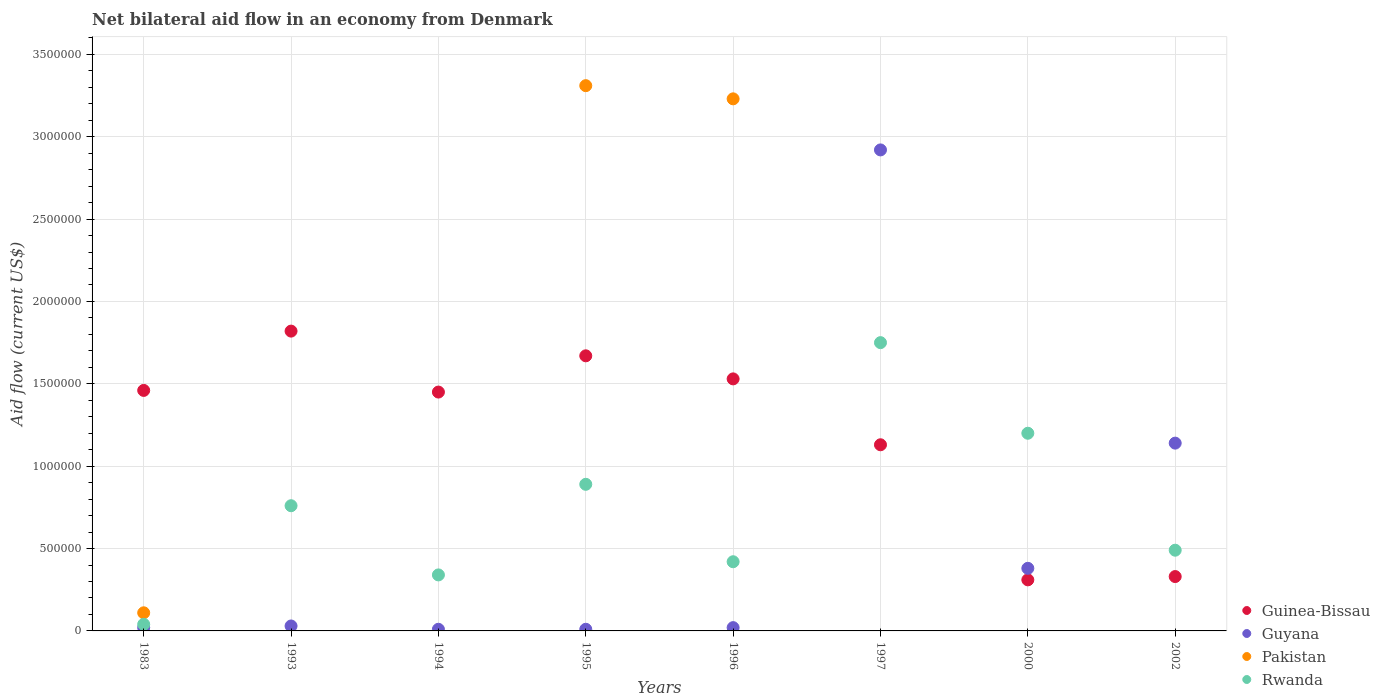How many different coloured dotlines are there?
Your answer should be very brief. 4. Across all years, what is the maximum net bilateral aid flow in Pakistan?
Ensure brevity in your answer.  3.31e+06. In which year was the net bilateral aid flow in Pakistan maximum?
Offer a very short reply. 1995. What is the total net bilateral aid flow in Guinea-Bissau in the graph?
Provide a short and direct response. 9.70e+06. What is the difference between the net bilateral aid flow in Rwanda in 1997 and the net bilateral aid flow in Pakistan in 1996?
Ensure brevity in your answer.  -1.48e+06. What is the average net bilateral aid flow in Rwanda per year?
Make the answer very short. 7.36e+05. In the year 2002, what is the difference between the net bilateral aid flow in Guyana and net bilateral aid flow in Rwanda?
Your response must be concise. 6.50e+05. In how many years, is the net bilateral aid flow in Rwanda greater than 1200000 US$?
Give a very brief answer. 1. What is the ratio of the net bilateral aid flow in Guinea-Bissau in 1996 to that in 2000?
Your response must be concise. 4.94. Is the net bilateral aid flow in Rwanda in 1983 less than that in 2002?
Give a very brief answer. Yes. What is the difference between the highest and the second highest net bilateral aid flow in Guinea-Bissau?
Offer a very short reply. 1.50e+05. What is the difference between the highest and the lowest net bilateral aid flow in Rwanda?
Your answer should be compact. 1.71e+06. Is it the case that in every year, the sum of the net bilateral aid flow in Guyana and net bilateral aid flow in Guinea-Bissau  is greater than the sum of net bilateral aid flow in Pakistan and net bilateral aid flow in Rwanda?
Offer a terse response. No. Does the net bilateral aid flow in Guinea-Bissau monotonically increase over the years?
Your answer should be very brief. No. Is the net bilateral aid flow in Pakistan strictly greater than the net bilateral aid flow in Guinea-Bissau over the years?
Keep it short and to the point. No. Is the net bilateral aid flow in Pakistan strictly less than the net bilateral aid flow in Guinea-Bissau over the years?
Make the answer very short. No. How many dotlines are there?
Offer a very short reply. 4. What is the difference between two consecutive major ticks on the Y-axis?
Keep it short and to the point. 5.00e+05. Are the values on the major ticks of Y-axis written in scientific E-notation?
Provide a short and direct response. No. Does the graph contain grids?
Provide a succinct answer. Yes. What is the title of the graph?
Your answer should be compact. Net bilateral aid flow in an economy from Denmark. Does "Belize" appear as one of the legend labels in the graph?
Ensure brevity in your answer.  No. What is the label or title of the Y-axis?
Offer a terse response. Aid flow (current US$). What is the Aid flow (current US$) of Guinea-Bissau in 1983?
Give a very brief answer. 1.46e+06. What is the Aid flow (current US$) in Guinea-Bissau in 1993?
Give a very brief answer. 1.82e+06. What is the Aid flow (current US$) in Guyana in 1993?
Provide a short and direct response. 3.00e+04. What is the Aid flow (current US$) in Rwanda in 1993?
Ensure brevity in your answer.  7.60e+05. What is the Aid flow (current US$) in Guinea-Bissau in 1994?
Offer a very short reply. 1.45e+06. What is the Aid flow (current US$) in Guyana in 1994?
Your answer should be compact. 10000. What is the Aid flow (current US$) in Rwanda in 1994?
Make the answer very short. 3.40e+05. What is the Aid flow (current US$) in Guinea-Bissau in 1995?
Ensure brevity in your answer.  1.67e+06. What is the Aid flow (current US$) in Pakistan in 1995?
Provide a short and direct response. 3.31e+06. What is the Aid flow (current US$) of Rwanda in 1995?
Make the answer very short. 8.90e+05. What is the Aid flow (current US$) of Guinea-Bissau in 1996?
Make the answer very short. 1.53e+06. What is the Aid flow (current US$) of Pakistan in 1996?
Give a very brief answer. 3.23e+06. What is the Aid flow (current US$) of Guinea-Bissau in 1997?
Ensure brevity in your answer.  1.13e+06. What is the Aid flow (current US$) in Guyana in 1997?
Ensure brevity in your answer.  2.92e+06. What is the Aid flow (current US$) of Rwanda in 1997?
Your answer should be compact. 1.75e+06. What is the Aid flow (current US$) in Pakistan in 2000?
Make the answer very short. 0. What is the Aid flow (current US$) of Rwanda in 2000?
Ensure brevity in your answer.  1.20e+06. What is the Aid flow (current US$) in Guyana in 2002?
Provide a short and direct response. 1.14e+06. Across all years, what is the maximum Aid flow (current US$) in Guinea-Bissau?
Offer a terse response. 1.82e+06. Across all years, what is the maximum Aid flow (current US$) in Guyana?
Your response must be concise. 2.92e+06. Across all years, what is the maximum Aid flow (current US$) in Pakistan?
Give a very brief answer. 3.31e+06. Across all years, what is the maximum Aid flow (current US$) of Rwanda?
Make the answer very short. 1.75e+06. Across all years, what is the minimum Aid flow (current US$) in Guinea-Bissau?
Provide a short and direct response. 3.10e+05. Across all years, what is the minimum Aid flow (current US$) in Pakistan?
Offer a terse response. 0. What is the total Aid flow (current US$) in Guinea-Bissau in the graph?
Ensure brevity in your answer.  9.70e+06. What is the total Aid flow (current US$) in Guyana in the graph?
Make the answer very short. 4.53e+06. What is the total Aid flow (current US$) of Pakistan in the graph?
Give a very brief answer. 6.65e+06. What is the total Aid flow (current US$) in Rwanda in the graph?
Your answer should be very brief. 5.89e+06. What is the difference between the Aid flow (current US$) of Guinea-Bissau in 1983 and that in 1993?
Make the answer very short. -3.60e+05. What is the difference between the Aid flow (current US$) of Guyana in 1983 and that in 1993?
Your answer should be very brief. -10000. What is the difference between the Aid flow (current US$) in Rwanda in 1983 and that in 1993?
Make the answer very short. -7.20e+05. What is the difference between the Aid flow (current US$) in Guinea-Bissau in 1983 and that in 1994?
Ensure brevity in your answer.  10000. What is the difference between the Aid flow (current US$) in Guyana in 1983 and that in 1994?
Provide a short and direct response. 10000. What is the difference between the Aid flow (current US$) of Rwanda in 1983 and that in 1994?
Provide a short and direct response. -3.00e+05. What is the difference between the Aid flow (current US$) of Guyana in 1983 and that in 1995?
Make the answer very short. 10000. What is the difference between the Aid flow (current US$) in Pakistan in 1983 and that in 1995?
Make the answer very short. -3.20e+06. What is the difference between the Aid flow (current US$) of Rwanda in 1983 and that in 1995?
Give a very brief answer. -8.50e+05. What is the difference between the Aid flow (current US$) of Guyana in 1983 and that in 1996?
Your answer should be compact. 0. What is the difference between the Aid flow (current US$) of Pakistan in 1983 and that in 1996?
Ensure brevity in your answer.  -3.12e+06. What is the difference between the Aid flow (current US$) in Rwanda in 1983 and that in 1996?
Offer a terse response. -3.80e+05. What is the difference between the Aid flow (current US$) of Guyana in 1983 and that in 1997?
Provide a succinct answer. -2.90e+06. What is the difference between the Aid flow (current US$) in Rwanda in 1983 and that in 1997?
Provide a short and direct response. -1.71e+06. What is the difference between the Aid flow (current US$) in Guinea-Bissau in 1983 and that in 2000?
Provide a short and direct response. 1.15e+06. What is the difference between the Aid flow (current US$) in Guyana in 1983 and that in 2000?
Your answer should be very brief. -3.60e+05. What is the difference between the Aid flow (current US$) of Rwanda in 1983 and that in 2000?
Keep it short and to the point. -1.16e+06. What is the difference between the Aid flow (current US$) in Guinea-Bissau in 1983 and that in 2002?
Your answer should be very brief. 1.13e+06. What is the difference between the Aid flow (current US$) in Guyana in 1983 and that in 2002?
Give a very brief answer. -1.12e+06. What is the difference between the Aid flow (current US$) in Rwanda in 1983 and that in 2002?
Offer a terse response. -4.50e+05. What is the difference between the Aid flow (current US$) in Rwanda in 1993 and that in 1994?
Offer a terse response. 4.20e+05. What is the difference between the Aid flow (current US$) of Guinea-Bissau in 1993 and that in 1995?
Offer a very short reply. 1.50e+05. What is the difference between the Aid flow (current US$) in Guyana in 1993 and that in 1995?
Keep it short and to the point. 2.00e+04. What is the difference between the Aid flow (current US$) of Guinea-Bissau in 1993 and that in 1996?
Offer a very short reply. 2.90e+05. What is the difference between the Aid flow (current US$) in Guyana in 1993 and that in 1996?
Your answer should be compact. 10000. What is the difference between the Aid flow (current US$) in Guinea-Bissau in 1993 and that in 1997?
Offer a very short reply. 6.90e+05. What is the difference between the Aid flow (current US$) in Guyana in 1993 and that in 1997?
Your answer should be very brief. -2.89e+06. What is the difference between the Aid flow (current US$) in Rwanda in 1993 and that in 1997?
Your answer should be compact. -9.90e+05. What is the difference between the Aid flow (current US$) in Guinea-Bissau in 1993 and that in 2000?
Give a very brief answer. 1.51e+06. What is the difference between the Aid flow (current US$) in Guyana in 1993 and that in 2000?
Provide a succinct answer. -3.50e+05. What is the difference between the Aid flow (current US$) of Rwanda in 1993 and that in 2000?
Your answer should be compact. -4.40e+05. What is the difference between the Aid flow (current US$) in Guinea-Bissau in 1993 and that in 2002?
Your answer should be compact. 1.49e+06. What is the difference between the Aid flow (current US$) in Guyana in 1993 and that in 2002?
Provide a short and direct response. -1.11e+06. What is the difference between the Aid flow (current US$) in Rwanda in 1993 and that in 2002?
Ensure brevity in your answer.  2.70e+05. What is the difference between the Aid flow (current US$) in Guyana in 1994 and that in 1995?
Keep it short and to the point. 0. What is the difference between the Aid flow (current US$) of Rwanda in 1994 and that in 1995?
Your answer should be very brief. -5.50e+05. What is the difference between the Aid flow (current US$) in Guinea-Bissau in 1994 and that in 1996?
Ensure brevity in your answer.  -8.00e+04. What is the difference between the Aid flow (current US$) in Rwanda in 1994 and that in 1996?
Ensure brevity in your answer.  -8.00e+04. What is the difference between the Aid flow (current US$) of Guinea-Bissau in 1994 and that in 1997?
Keep it short and to the point. 3.20e+05. What is the difference between the Aid flow (current US$) in Guyana in 1994 and that in 1997?
Give a very brief answer. -2.91e+06. What is the difference between the Aid flow (current US$) in Rwanda in 1994 and that in 1997?
Keep it short and to the point. -1.41e+06. What is the difference between the Aid flow (current US$) in Guinea-Bissau in 1994 and that in 2000?
Your response must be concise. 1.14e+06. What is the difference between the Aid flow (current US$) of Guyana in 1994 and that in 2000?
Offer a very short reply. -3.70e+05. What is the difference between the Aid flow (current US$) in Rwanda in 1994 and that in 2000?
Provide a succinct answer. -8.60e+05. What is the difference between the Aid flow (current US$) in Guinea-Bissau in 1994 and that in 2002?
Offer a terse response. 1.12e+06. What is the difference between the Aid flow (current US$) of Guyana in 1994 and that in 2002?
Give a very brief answer. -1.13e+06. What is the difference between the Aid flow (current US$) in Rwanda in 1994 and that in 2002?
Offer a terse response. -1.50e+05. What is the difference between the Aid flow (current US$) of Guinea-Bissau in 1995 and that in 1996?
Make the answer very short. 1.40e+05. What is the difference between the Aid flow (current US$) in Rwanda in 1995 and that in 1996?
Your response must be concise. 4.70e+05. What is the difference between the Aid flow (current US$) in Guinea-Bissau in 1995 and that in 1997?
Provide a succinct answer. 5.40e+05. What is the difference between the Aid flow (current US$) in Guyana in 1995 and that in 1997?
Keep it short and to the point. -2.91e+06. What is the difference between the Aid flow (current US$) of Rwanda in 1995 and that in 1997?
Make the answer very short. -8.60e+05. What is the difference between the Aid flow (current US$) in Guinea-Bissau in 1995 and that in 2000?
Your response must be concise. 1.36e+06. What is the difference between the Aid flow (current US$) of Guyana in 1995 and that in 2000?
Ensure brevity in your answer.  -3.70e+05. What is the difference between the Aid flow (current US$) in Rwanda in 1995 and that in 2000?
Your response must be concise. -3.10e+05. What is the difference between the Aid flow (current US$) in Guinea-Bissau in 1995 and that in 2002?
Your answer should be compact. 1.34e+06. What is the difference between the Aid flow (current US$) in Guyana in 1995 and that in 2002?
Offer a very short reply. -1.13e+06. What is the difference between the Aid flow (current US$) in Rwanda in 1995 and that in 2002?
Give a very brief answer. 4.00e+05. What is the difference between the Aid flow (current US$) of Guyana in 1996 and that in 1997?
Provide a succinct answer. -2.90e+06. What is the difference between the Aid flow (current US$) in Rwanda in 1996 and that in 1997?
Offer a terse response. -1.33e+06. What is the difference between the Aid flow (current US$) in Guinea-Bissau in 1996 and that in 2000?
Ensure brevity in your answer.  1.22e+06. What is the difference between the Aid flow (current US$) in Guyana in 1996 and that in 2000?
Offer a terse response. -3.60e+05. What is the difference between the Aid flow (current US$) in Rwanda in 1996 and that in 2000?
Your response must be concise. -7.80e+05. What is the difference between the Aid flow (current US$) in Guinea-Bissau in 1996 and that in 2002?
Provide a succinct answer. 1.20e+06. What is the difference between the Aid flow (current US$) in Guyana in 1996 and that in 2002?
Your response must be concise. -1.12e+06. What is the difference between the Aid flow (current US$) in Rwanda in 1996 and that in 2002?
Your answer should be very brief. -7.00e+04. What is the difference between the Aid flow (current US$) in Guinea-Bissau in 1997 and that in 2000?
Keep it short and to the point. 8.20e+05. What is the difference between the Aid flow (current US$) of Guyana in 1997 and that in 2000?
Offer a terse response. 2.54e+06. What is the difference between the Aid flow (current US$) of Rwanda in 1997 and that in 2000?
Your answer should be compact. 5.50e+05. What is the difference between the Aid flow (current US$) in Guyana in 1997 and that in 2002?
Make the answer very short. 1.78e+06. What is the difference between the Aid flow (current US$) of Rwanda in 1997 and that in 2002?
Provide a succinct answer. 1.26e+06. What is the difference between the Aid flow (current US$) of Guinea-Bissau in 2000 and that in 2002?
Provide a succinct answer. -2.00e+04. What is the difference between the Aid flow (current US$) in Guyana in 2000 and that in 2002?
Ensure brevity in your answer.  -7.60e+05. What is the difference between the Aid flow (current US$) in Rwanda in 2000 and that in 2002?
Keep it short and to the point. 7.10e+05. What is the difference between the Aid flow (current US$) of Guinea-Bissau in 1983 and the Aid flow (current US$) of Guyana in 1993?
Provide a short and direct response. 1.43e+06. What is the difference between the Aid flow (current US$) in Guinea-Bissau in 1983 and the Aid flow (current US$) in Rwanda in 1993?
Provide a short and direct response. 7.00e+05. What is the difference between the Aid flow (current US$) in Guyana in 1983 and the Aid flow (current US$) in Rwanda in 1993?
Keep it short and to the point. -7.40e+05. What is the difference between the Aid flow (current US$) in Pakistan in 1983 and the Aid flow (current US$) in Rwanda in 1993?
Provide a short and direct response. -6.50e+05. What is the difference between the Aid flow (current US$) of Guinea-Bissau in 1983 and the Aid flow (current US$) of Guyana in 1994?
Provide a short and direct response. 1.45e+06. What is the difference between the Aid flow (current US$) in Guinea-Bissau in 1983 and the Aid flow (current US$) in Rwanda in 1994?
Ensure brevity in your answer.  1.12e+06. What is the difference between the Aid flow (current US$) in Guyana in 1983 and the Aid flow (current US$) in Rwanda in 1994?
Provide a short and direct response. -3.20e+05. What is the difference between the Aid flow (current US$) of Guinea-Bissau in 1983 and the Aid flow (current US$) of Guyana in 1995?
Provide a succinct answer. 1.45e+06. What is the difference between the Aid flow (current US$) of Guinea-Bissau in 1983 and the Aid flow (current US$) of Pakistan in 1995?
Give a very brief answer. -1.85e+06. What is the difference between the Aid flow (current US$) of Guinea-Bissau in 1983 and the Aid flow (current US$) of Rwanda in 1995?
Offer a terse response. 5.70e+05. What is the difference between the Aid flow (current US$) of Guyana in 1983 and the Aid flow (current US$) of Pakistan in 1995?
Offer a very short reply. -3.29e+06. What is the difference between the Aid flow (current US$) in Guyana in 1983 and the Aid flow (current US$) in Rwanda in 1995?
Your answer should be compact. -8.70e+05. What is the difference between the Aid flow (current US$) of Pakistan in 1983 and the Aid flow (current US$) of Rwanda in 1995?
Make the answer very short. -7.80e+05. What is the difference between the Aid flow (current US$) of Guinea-Bissau in 1983 and the Aid flow (current US$) of Guyana in 1996?
Offer a very short reply. 1.44e+06. What is the difference between the Aid flow (current US$) in Guinea-Bissau in 1983 and the Aid flow (current US$) in Pakistan in 1996?
Make the answer very short. -1.77e+06. What is the difference between the Aid flow (current US$) of Guinea-Bissau in 1983 and the Aid flow (current US$) of Rwanda in 1996?
Give a very brief answer. 1.04e+06. What is the difference between the Aid flow (current US$) of Guyana in 1983 and the Aid flow (current US$) of Pakistan in 1996?
Ensure brevity in your answer.  -3.21e+06. What is the difference between the Aid flow (current US$) of Guyana in 1983 and the Aid flow (current US$) of Rwanda in 1996?
Give a very brief answer. -4.00e+05. What is the difference between the Aid flow (current US$) in Pakistan in 1983 and the Aid flow (current US$) in Rwanda in 1996?
Keep it short and to the point. -3.10e+05. What is the difference between the Aid flow (current US$) of Guinea-Bissau in 1983 and the Aid flow (current US$) of Guyana in 1997?
Ensure brevity in your answer.  -1.46e+06. What is the difference between the Aid flow (current US$) of Guyana in 1983 and the Aid flow (current US$) of Rwanda in 1997?
Offer a very short reply. -1.73e+06. What is the difference between the Aid flow (current US$) in Pakistan in 1983 and the Aid flow (current US$) in Rwanda in 1997?
Ensure brevity in your answer.  -1.64e+06. What is the difference between the Aid flow (current US$) in Guinea-Bissau in 1983 and the Aid flow (current US$) in Guyana in 2000?
Your answer should be very brief. 1.08e+06. What is the difference between the Aid flow (current US$) in Guinea-Bissau in 1983 and the Aid flow (current US$) in Rwanda in 2000?
Provide a succinct answer. 2.60e+05. What is the difference between the Aid flow (current US$) in Guyana in 1983 and the Aid flow (current US$) in Rwanda in 2000?
Provide a succinct answer. -1.18e+06. What is the difference between the Aid flow (current US$) of Pakistan in 1983 and the Aid flow (current US$) of Rwanda in 2000?
Your response must be concise. -1.09e+06. What is the difference between the Aid flow (current US$) in Guinea-Bissau in 1983 and the Aid flow (current US$) in Rwanda in 2002?
Your answer should be compact. 9.70e+05. What is the difference between the Aid flow (current US$) in Guyana in 1983 and the Aid flow (current US$) in Rwanda in 2002?
Make the answer very short. -4.70e+05. What is the difference between the Aid flow (current US$) in Pakistan in 1983 and the Aid flow (current US$) in Rwanda in 2002?
Your response must be concise. -3.80e+05. What is the difference between the Aid flow (current US$) in Guinea-Bissau in 1993 and the Aid flow (current US$) in Guyana in 1994?
Keep it short and to the point. 1.81e+06. What is the difference between the Aid flow (current US$) in Guinea-Bissau in 1993 and the Aid flow (current US$) in Rwanda in 1994?
Provide a short and direct response. 1.48e+06. What is the difference between the Aid flow (current US$) of Guyana in 1993 and the Aid flow (current US$) of Rwanda in 1994?
Provide a short and direct response. -3.10e+05. What is the difference between the Aid flow (current US$) of Guinea-Bissau in 1993 and the Aid flow (current US$) of Guyana in 1995?
Ensure brevity in your answer.  1.81e+06. What is the difference between the Aid flow (current US$) in Guinea-Bissau in 1993 and the Aid flow (current US$) in Pakistan in 1995?
Your answer should be compact. -1.49e+06. What is the difference between the Aid flow (current US$) in Guinea-Bissau in 1993 and the Aid flow (current US$) in Rwanda in 1995?
Provide a succinct answer. 9.30e+05. What is the difference between the Aid flow (current US$) of Guyana in 1993 and the Aid flow (current US$) of Pakistan in 1995?
Your answer should be very brief. -3.28e+06. What is the difference between the Aid flow (current US$) in Guyana in 1993 and the Aid flow (current US$) in Rwanda in 1995?
Provide a succinct answer. -8.60e+05. What is the difference between the Aid flow (current US$) of Guinea-Bissau in 1993 and the Aid flow (current US$) of Guyana in 1996?
Your answer should be very brief. 1.80e+06. What is the difference between the Aid flow (current US$) in Guinea-Bissau in 1993 and the Aid flow (current US$) in Pakistan in 1996?
Give a very brief answer. -1.41e+06. What is the difference between the Aid flow (current US$) in Guinea-Bissau in 1993 and the Aid flow (current US$) in Rwanda in 1996?
Offer a terse response. 1.40e+06. What is the difference between the Aid flow (current US$) of Guyana in 1993 and the Aid flow (current US$) of Pakistan in 1996?
Give a very brief answer. -3.20e+06. What is the difference between the Aid flow (current US$) of Guyana in 1993 and the Aid flow (current US$) of Rwanda in 1996?
Your answer should be very brief. -3.90e+05. What is the difference between the Aid flow (current US$) in Guinea-Bissau in 1993 and the Aid flow (current US$) in Guyana in 1997?
Offer a very short reply. -1.10e+06. What is the difference between the Aid flow (current US$) of Guyana in 1993 and the Aid flow (current US$) of Rwanda in 1997?
Your response must be concise. -1.72e+06. What is the difference between the Aid flow (current US$) in Guinea-Bissau in 1993 and the Aid flow (current US$) in Guyana in 2000?
Give a very brief answer. 1.44e+06. What is the difference between the Aid flow (current US$) of Guinea-Bissau in 1993 and the Aid flow (current US$) of Rwanda in 2000?
Your response must be concise. 6.20e+05. What is the difference between the Aid flow (current US$) of Guyana in 1993 and the Aid flow (current US$) of Rwanda in 2000?
Your answer should be very brief. -1.17e+06. What is the difference between the Aid flow (current US$) in Guinea-Bissau in 1993 and the Aid flow (current US$) in Guyana in 2002?
Make the answer very short. 6.80e+05. What is the difference between the Aid flow (current US$) of Guinea-Bissau in 1993 and the Aid flow (current US$) of Rwanda in 2002?
Keep it short and to the point. 1.33e+06. What is the difference between the Aid flow (current US$) of Guyana in 1993 and the Aid flow (current US$) of Rwanda in 2002?
Ensure brevity in your answer.  -4.60e+05. What is the difference between the Aid flow (current US$) in Guinea-Bissau in 1994 and the Aid flow (current US$) in Guyana in 1995?
Ensure brevity in your answer.  1.44e+06. What is the difference between the Aid flow (current US$) in Guinea-Bissau in 1994 and the Aid flow (current US$) in Pakistan in 1995?
Give a very brief answer. -1.86e+06. What is the difference between the Aid flow (current US$) in Guinea-Bissau in 1994 and the Aid flow (current US$) in Rwanda in 1995?
Offer a very short reply. 5.60e+05. What is the difference between the Aid flow (current US$) of Guyana in 1994 and the Aid flow (current US$) of Pakistan in 1995?
Keep it short and to the point. -3.30e+06. What is the difference between the Aid flow (current US$) in Guyana in 1994 and the Aid flow (current US$) in Rwanda in 1995?
Offer a very short reply. -8.80e+05. What is the difference between the Aid flow (current US$) of Guinea-Bissau in 1994 and the Aid flow (current US$) of Guyana in 1996?
Make the answer very short. 1.43e+06. What is the difference between the Aid flow (current US$) of Guinea-Bissau in 1994 and the Aid flow (current US$) of Pakistan in 1996?
Your response must be concise. -1.78e+06. What is the difference between the Aid flow (current US$) of Guinea-Bissau in 1994 and the Aid flow (current US$) of Rwanda in 1996?
Provide a short and direct response. 1.03e+06. What is the difference between the Aid flow (current US$) in Guyana in 1994 and the Aid flow (current US$) in Pakistan in 1996?
Your response must be concise. -3.22e+06. What is the difference between the Aid flow (current US$) of Guyana in 1994 and the Aid flow (current US$) of Rwanda in 1996?
Make the answer very short. -4.10e+05. What is the difference between the Aid flow (current US$) in Guinea-Bissau in 1994 and the Aid flow (current US$) in Guyana in 1997?
Provide a succinct answer. -1.47e+06. What is the difference between the Aid flow (current US$) in Guinea-Bissau in 1994 and the Aid flow (current US$) in Rwanda in 1997?
Offer a very short reply. -3.00e+05. What is the difference between the Aid flow (current US$) in Guyana in 1994 and the Aid flow (current US$) in Rwanda in 1997?
Your response must be concise. -1.74e+06. What is the difference between the Aid flow (current US$) of Guinea-Bissau in 1994 and the Aid flow (current US$) of Guyana in 2000?
Offer a terse response. 1.07e+06. What is the difference between the Aid flow (current US$) of Guyana in 1994 and the Aid flow (current US$) of Rwanda in 2000?
Give a very brief answer. -1.19e+06. What is the difference between the Aid flow (current US$) of Guinea-Bissau in 1994 and the Aid flow (current US$) of Rwanda in 2002?
Make the answer very short. 9.60e+05. What is the difference between the Aid flow (current US$) in Guyana in 1994 and the Aid flow (current US$) in Rwanda in 2002?
Keep it short and to the point. -4.80e+05. What is the difference between the Aid flow (current US$) of Guinea-Bissau in 1995 and the Aid flow (current US$) of Guyana in 1996?
Your answer should be very brief. 1.65e+06. What is the difference between the Aid flow (current US$) in Guinea-Bissau in 1995 and the Aid flow (current US$) in Pakistan in 1996?
Your answer should be compact. -1.56e+06. What is the difference between the Aid flow (current US$) in Guinea-Bissau in 1995 and the Aid flow (current US$) in Rwanda in 1996?
Ensure brevity in your answer.  1.25e+06. What is the difference between the Aid flow (current US$) in Guyana in 1995 and the Aid flow (current US$) in Pakistan in 1996?
Ensure brevity in your answer.  -3.22e+06. What is the difference between the Aid flow (current US$) in Guyana in 1995 and the Aid flow (current US$) in Rwanda in 1996?
Your response must be concise. -4.10e+05. What is the difference between the Aid flow (current US$) in Pakistan in 1995 and the Aid flow (current US$) in Rwanda in 1996?
Keep it short and to the point. 2.89e+06. What is the difference between the Aid flow (current US$) in Guinea-Bissau in 1995 and the Aid flow (current US$) in Guyana in 1997?
Provide a succinct answer. -1.25e+06. What is the difference between the Aid flow (current US$) of Guyana in 1995 and the Aid flow (current US$) of Rwanda in 1997?
Provide a succinct answer. -1.74e+06. What is the difference between the Aid flow (current US$) in Pakistan in 1995 and the Aid flow (current US$) in Rwanda in 1997?
Provide a succinct answer. 1.56e+06. What is the difference between the Aid flow (current US$) of Guinea-Bissau in 1995 and the Aid flow (current US$) of Guyana in 2000?
Provide a short and direct response. 1.29e+06. What is the difference between the Aid flow (current US$) in Guyana in 1995 and the Aid flow (current US$) in Rwanda in 2000?
Your answer should be very brief. -1.19e+06. What is the difference between the Aid flow (current US$) of Pakistan in 1995 and the Aid flow (current US$) of Rwanda in 2000?
Provide a short and direct response. 2.11e+06. What is the difference between the Aid flow (current US$) in Guinea-Bissau in 1995 and the Aid flow (current US$) in Guyana in 2002?
Make the answer very short. 5.30e+05. What is the difference between the Aid flow (current US$) in Guinea-Bissau in 1995 and the Aid flow (current US$) in Rwanda in 2002?
Keep it short and to the point. 1.18e+06. What is the difference between the Aid flow (current US$) of Guyana in 1995 and the Aid flow (current US$) of Rwanda in 2002?
Make the answer very short. -4.80e+05. What is the difference between the Aid flow (current US$) of Pakistan in 1995 and the Aid flow (current US$) of Rwanda in 2002?
Keep it short and to the point. 2.82e+06. What is the difference between the Aid flow (current US$) in Guinea-Bissau in 1996 and the Aid flow (current US$) in Guyana in 1997?
Keep it short and to the point. -1.39e+06. What is the difference between the Aid flow (current US$) of Guinea-Bissau in 1996 and the Aid flow (current US$) of Rwanda in 1997?
Offer a terse response. -2.20e+05. What is the difference between the Aid flow (current US$) of Guyana in 1996 and the Aid flow (current US$) of Rwanda in 1997?
Give a very brief answer. -1.73e+06. What is the difference between the Aid flow (current US$) of Pakistan in 1996 and the Aid flow (current US$) of Rwanda in 1997?
Give a very brief answer. 1.48e+06. What is the difference between the Aid flow (current US$) in Guinea-Bissau in 1996 and the Aid flow (current US$) in Guyana in 2000?
Ensure brevity in your answer.  1.15e+06. What is the difference between the Aid flow (current US$) in Guinea-Bissau in 1996 and the Aid flow (current US$) in Rwanda in 2000?
Your answer should be compact. 3.30e+05. What is the difference between the Aid flow (current US$) of Guyana in 1996 and the Aid flow (current US$) of Rwanda in 2000?
Provide a short and direct response. -1.18e+06. What is the difference between the Aid flow (current US$) of Pakistan in 1996 and the Aid flow (current US$) of Rwanda in 2000?
Make the answer very short. 2.03e+06. What is the difference between the Aid flow (current US$) in Guinea-Bissau in 1996 and the Aid flow (current US$) in Guyana in 2002?
Offer a very short reply. 3.90e+05. What is the difference between the Aid flow (current US$) of Guinea-Bissau in 1996 and the Aid flow (current US$) of Rwanda in 2002?
Offer a very short reply. 1.04e+06. What is the difference between the Aid flow (current US$) of Guyana in 1996 and the Aid flow (current US$) of Rwanda in 2002?
Your answer should be very brief. -4.70e+05. What is the difference between the Aid flow (current US$) in Pakistan in 1996 and the Aid flow (current US$) in Rwanda in 2002?
Your answer should be compact. 2.74e+06. What is the difference between the Aid flow (current US$) in Guinea-Bissau in 1997 and the Aid flow (current US$) in Guyana in 2000?
Make the answer very short. 7.50e+05. What is the difference between the Aid flow (current US$) of Guinea-Bissau in 1997 and the Aid flow (current US$) of Rwanda in 2000?
Provide a short and direct response. -7.00e+04. What is the difference between the Aid flow (current US$) in Guyana in 1997 and the Aid flow (current US$) in Rwanda in 2000?
Ensure brevity in your answer.  1.72e+06. What is the difference between the Aid flow (current US$) of Guinea-Bissau in 1997 and the Aid flow (current US$) of Guyana in 2002?
Give a very brief answer. -10000. What is the difference between the Aid flow (current US$) of Guinea-Bissau in 1997 and the Aid flow (current US$) of Rwanda in 2002?
Provide a succinct answer. 6.40e+05. What is the difference between the Aid flow (current US$) in Guyana in 1997 and the Aid flow (current US$) in Rwanda in 2002?
Provide a short and direct response. 2.43e+06. What is the difference between the Aid flow (current US$) of Guinea-Bissau in 2000 and the Aid flow (current US$) of Guyana in 2002?
Your answer should be very brief. -8.30e+05. What is the difference between the Aid flow (current US$) in Guinea-Bissau in 2000 and the Aid flow (current US$) in Rwanda in 2002?
Ensure brevity in your answer.  -1.80e+05. What is the average Aid flow (current US$) in Guinea-Bissau per year?
Your response must be concise. 1.21e+06. What is the average Aid flow (current US$) in Guyana per year?
Offer a terse response. 5.66e+05. What is the average Aid flow (current US$) of Pakistan per year?
Your answer should be compact. 8.31e+05. What is the average Aid flow (current US$) of Rwanda per year?
Give a very brief answer. 7.36e+05. In the year 1983, what is the difference between the Aid flow (current US$) of Guinea-Bissau and Aid flow (current US$) of Guyana?
Keep it short and to the point. 1.44e+06. In the year 1983, what is the difference between the Aid flow (current US$) of Guinea-Bissau and Aid flow (current US$) of Pakistan?
Provide a short and direct response. 1.35e+06. In the year 1983, what is the difference between the Aid flow (current US$) of Guinea-Bissau and Aid flow (current US$) of Rwanda?
Ensure brevity in your answer.  1.42e+06. In the year 1983, what is the difference between the Aid flow (current US$) in Guyana and Aid flow (current US$) in Pakistan?
Your response must be concise. -9.00e+04. In the year 1983, what is the difference between the Aid flow (current US$) of Guyana and Aid flow (current US$) of Rwanda?
Provide a short and direct response. -2.00e+04. In the year 1993, what is the difference between the Aid flow (current US$) in Guinea-Bissau and Aid flow (current US$) in Guyana?
Give a very brief answer. 1.79e+06. In the year 1993, what is the difference between the Aid flow (current US$) of Guinea-Bissau and Aid flow (current US$) of Rwanda?
Your answer should be compact. 1.06e+06. In the year 1993, what is the difference between the Aid flow (current US$) of Guyana and Aid flow (current US$) of Rwanda?
Give a very brief answer. -7.30e+05. In the year 1994, what is the difference between the Aid flow (current US$) in Guinea-Bissau and Aid flow (current US$) in Guyana?
Give a very brief answer. 1.44e+06. In the year 1994, what is the difference between the Aid flow (current US$) in Guinea-Bissau and Aid flow (current US$) in Rwanda?
Make the answer very short. 1.11e+06. In the year 1994, what is the difference between the Aid flow (current US$) of Guyana and Aid flow (current US$) of Rwanda?
Make the answer very short. -3.30e+05. In the year 1995, what is the difference between the Aid flow (current US$) in Guinea-Bissau and Aid flow (current US$) in Guyana?
Your response must be concise. 1.66e+06. In the year 1995, what is the difference between the Aid flow (current US$) in Guinea-Bissau and Aid flow (current US$) in Pakistan?
Your response must be concise. -1.64e+06. In the year 1995, what is the difference between the Aid flow (current US$) in Guinea-Bissau and Aid flow (current US$) in Rwanda?
Your answer should be compact. 7.80e+05. In the year 1995, what is the difference between the Aid flow (current US$) in Guyana and Aid flow (current US$) in Pakistan?
Make the answer very short. -3.30e+06. In the year 1995, what is the difference between the Aid flow (current US$) in Guyana and Aid flow (current US$) in Rwanda?
Keep it short and to the point. -8.80e+05. In the year 1995, what is the difference between the Aid flow (current US$) in Pakistan and Aid flow (current US$) in Rwanda?
Offer a very short reply. 2.42e+06. In the year 1996, what is the difference between the Aid flow (current US$) of Guinea-Bissau and Aid flow (current US$) of Guyana?
Your answer should be compact. 1.51e+06. In the year 1996, what is the difference between the Aid flow (current US$) of Guinea-Bissau and Aid flow (current US$) of Pakistan?
Provide a short and direct response. -1.70e+06. In the year 1996, what is the difference between the Aid flow (current US$) of Guinea-Bissau and Aid flow (current US$) of Rwanda?
Keep it short and to the point. 1.11e+06. In the year 1996, what is the difference between the Aid flow (current US$) in Guyana and Aid flow (current US$) in Pakistan?
Your answer should be very brief. -3.21e+06. In the year 1996, what is the difference between the Aid flow (current US$) in Guyana and Aid flow (current US$) in Rwanda?
Offer a terse response. -4.00e+05. In the year 1996, what is the difference between the Aid flow (current US$) in Pakistan and Aid flow (current US$) in Rwanda?
Keep it short and to the point. 2.81e+06. In the year 1997, what is the difference between the Aid flow (current US$) in Guinea-Bissau and Aid flow (current US$) in Guyana?
Your response must be concise. -1.79e+06. In the year 1997, what is the difference between the Aid flow (current US$) of Guinea-Bissau and Aid flow (current US$) of Rwanda?
Provide a short and direct response. -6.20e+05. In the year 1997, what is the difference between the Aid flow (current US$) in Guyana and Aid flow (current US$) in Rwanda?
Offer a terse response. 1.17e+06. In the year 2000, what is the difference between the Aid flow (current US$) of Guinea-Bissau and Aid flow (current US$) of Guyana?
Give a very brief answer. -7.00e+04. In the year 2000, what is the difference between the Aid flow (current US$) of Guinea-Bissau and Aid flow (current US$) of Rwanda?
Provide a short and direct response. -8.90e+05. In the year 2000, what is the difference between the Aid flow (current US$) in Guyana and Aid flow (current US$) in Rwanda?
Keep it short and to the point. -8.20e+05. In the year 2002, what is the difference between the Aid flow (current US$) in Guinea-Bissau and Aid flow (current US$) in Guyana?
Make the answer very short. -8.10e+05. In the year 2002, what is the difference between the Aid flow (current US$) of Guinea-Bissau and Aid flow (current US$) of Rwanda?
Offer a terse response. -1.60e+05. In the year 2002, what is the difference between the Aid flow (current US$) in Guyana and Aid flow (current US$) in Rwanda?
Offer a terse response. 6.50e+05. What is the ratio of the Aid flow (current US$) in Guinea-Bissau in 1983 to that in 1993?
Keep it short and to the point. 0.8. What is the ratio of the Aid flow (current US$) in Guyana in 1983 to that in 1993?
Provide a succinct answer. 0.67. What is the ratio of the Aid flow (current US$) in Rwanda in 1983 to that in 1993?
Your answer should be very brief. 0.05. What is the ratio of the Aid flow (current US$) in Rwanda in 1983 to that in 1994?
Give a very brief answer. 0.12. What is the ratio of the Aid flow (current US$) of Guinea-Bissau in 1983 to that in 1995?
Your response must be concise. 0.87. What is the ratio of the Aid flow (current US$) in Pakistan in 1983 to that in 1995?
Ensure brevity in your answer.  0.03. What is the ratio of the Aid flow (current US$) in Rwanda in 1983 to that in 1995?
Keep it short and to the point. 0.04. What is the ratio of the Aid flow (current US$) in Guinea-Bissau in 1983 to that in 1996?
Keep it short and to the point. 0.95. What is the ratio of the Aid flow (current US$) of Guyana in 1983 to that in 1996?
Make the answer very short. 1. What is the ratio of the Aid flow (current US$) of Pakistan in 1983 to that in 1996?
Your answer should be very brief. 0.03. What is the ratio of the Aid flow (current US$) in Rwanda in 1983 to that in 1996?
Give a very brief answer. 0.1. What is the ratio of the Aid flow (current US$) of Guinea-Bissau in 1983 to that in 1997?
Provide a succinct answer. 1.29. What is the ratio of the Aid flow (current US$) of Guyana in 1983 to that in 1997?
Your response must be concise. 0.01. What is the ratio of the Aid flow (current US$) of Rwanda in 1983 to that in 1997?
Give a very brief answer. 0.02. What is the ratio of the Aid flow (current US$) in Guinea-Bissau in 1983 to that in 2000?
Your answer should be compact. 4.71. What is the ratio of the Aid flow (current US$) in Guyana in 1983 to that in 2000?
Ensure brevity in your answer.  0.05. What is the ratio of the Aid flow (current US$) in Guinea-Bissau in 1983 to that in 2002?
Your answer should be very brief. 4.42. What is the ratio of the Aid flow (current US$) in Guyana in 1983 to that in 2002?
Provide a succinct answer. 0.02. What is the ratio of the Aid flow (current US$) in Rwanda in 1983 to that in 2002?
Keep it short and to the point. 0.08. What is the ratio of the Aid flow (current US$) of Guinea-Bissau in 1993 to that in 1994?
Offer a terse response. 1.26. What is the ratio of the Aid flow (current US$) of Rwanda in 1993 to that in 1994?
Provide a succinct answer. 2.24. What is the ratio of the Aid flow (current US$) of Guinea-Bissau in 1993 to that in 1995?
Provide a short and direct response. 1.09. What is the ratio of the Aid flow (current US$) in Guyana in 1993 to that in 1995?
Make the answer very short. 3. What is the ratio of the Aid flow (current US$) of Rwanda in 1993 to that in 1995?
Your response must be concise. 0.85. What is the ratio of the Aid flow (current US$) of Guinea-Bissau in 1993 to that in 1996?
Offer a very short reply. 1.19. What is the ratio of the Aid flow (current US$) of Rwanda in 1993 to that in 1996?
Provide a short and direct response. 1.81. What is the ratio of the Aid flow (current US$) of Guinea-Bissau in 1993 to that in 1997?
Ensure brevity in your answer.  1.61. What is the ratio of the Aid flow (current US$) of Guyana in 1993 to that in 1997?
Provide a short and direct response. 0.01. What is the ratio of the Aid flow (current US$) in Rwanda in 1993 to that in 1997?
Give a very brief answer. 0.43. What is the ratio of the Aid flow (current US$) in Guinea-Bissau in 1993 to that in 2000?
Give a very brief answer. 5.87. What is the ratio of the Aid flow (current US$) in Guyana in 1993 to that in 2000?
Provide a short and direct response. 0.08. What is the ratio of the Aid flow (current US$) in Rwanda in 1993 to that in 2000?
Give a very brief answer. 0.63. What is the ratio of the Aid flow (current US$) in Guinea-Bissau in 1993 to that in 2002?
Make the answer very short. 5.52. What is the ratio of the Aid flow (current US$) of Guyana in 1993 to that in 2002?
Give a very brief answer. 0.03. What is the ratio of the Aid flow (current US$) of Rwanda in 1993 to that in 2002?
Your response must be concise. 1.55. What is the ratio of the Aid flow (current US$) in Guinea-Bissau in 1994 to that in 1995?
Keep it short and to the point. 0.87. What is the ratio of the Aid flow (current US$) in Guyana in 1994 to that in 1995?
Provide a succinct answer. 1. What is the ratio of the Aid flow (current US$) of Rwanda in 1994 to that in 1995?
Your answer should be compact. 0.38. What is the ratio of the Aid flow (current US$) of Guinea-Bissau in 1994 to that in 1996?
Offer a very short reply. 0.95. What is the ratio of the Aid flow (current US$) in Rwanda in 1994 to that in 1996?
Make the answer very short. 0.81. What is the ratio of the Aid flow (current US$) of Guinea-Bissau in 1994 to that in 1997?
Your response must be concise. 1.28. What is the ratio of the Aid flow (current US$) of Guyana in 1994 to that in 1997?
Make the answer very short. 0. What is the ratio of the Aid flow (current US$) in Rwanda in 1994 to that in 1997?
Your answer should be very brief. 0.19. What is the ratio of the Aid flow (current US$) of Guinea-Bissau in 1994 to that in 2000?
Provide a short and direct response. 4.68. What is the ratio of the Aid flow (current US$) in Guyana in 1994 to that in 2000?
Offer a very short reply. 0.03. What is the ratio of the Aid flow (current US$) of Rwanda in 1994 to that in 2000?
Your answer should be compact. 0.28. What is the ratio of the Aid flow (current US$) of Guinea-Bissau in 1994 to that in 2002?
Ensure brevity in your answer.  4.39. What is the ratio of the Aid flow (current US$) of Guyana in 1994 to that in 2002?
Offer a very short reply. 0.01. What is the ratio of the Aid flow (current US$) in Rwanda in 1994 to that in 2002?
Provide a succinct answer. 0.69. What is the ratio of the Aid flow (current US$) in Guinea-Bissau in 1995 to that in 1996?
Offer a terse response. 1.09. What is the ratio of the Aid flow (current US$) of Guyana in 1995 to that in 1996?
Offer a terse response. 0.5. What is the ratio of the Aid flow (current US$) of Pakistan in 1995 to that in 1996?
Your answer should be very brief. 1.02. What is the ratio of the Aid flow (current US$) in Rwanda in 1995 to that in 1996?
Offer a very short reply. 2.12. What is the ratio of the Aid flow (current US$) in Guinea-Bissau in 1995 to that in 1997?
Your answer should be very brief. 1.48. What is the ratio of the Aid flow (current US$) of Guyana in 1995 to that in 1997?
Your response must be concise. 0. What is the ratio of the Aid flow (current US$) of Rwanda in 1995 to that in 1997?
Ensure brevity in your answer.  0.51. What is the ratio of the Aid flow (current US$) of Guinea-Bissau in 1995 to that in 2000?
Keep it short and to the point. 5.39. What is the ratio of the Aid flow (current US$) of Guyana in 1995 to that in 2000?
Offer a terse response. 0.03. What is the ratio of the Aid flow (current US$) of Rwanda in 1995 to that in 2000?
Your answer should be compact. 0.74. What is the ratio of the Aid flow (current US$) of Guinea-Bissau in 1995 to that in 2002?
Ensure brevity in your answer.  5.06. What is the ratio of the Aid flow (current US$) in Guyana in 1995 to that in 2002?
Your answer should be compact. 0.01. What is the ratio of the Aid flow (current US$) of Rwanda in 1995 to that in 2002?
Provide a succinct answer. 1.82. What is the ratio of the Aid flow (current US$) of Guinea-Bissau in 1996 to that in 1997?
Provide a short and direct response. 1.35. What is the ratio of the Aid flow (current US$) of Guyana in 1996 to that in 1997?
Your answer should be compact. 0.01. What is the ratio of the Aid flow (current US$) in Rwanda in 1996 to that in 1997?
Provide a succinct answer. 0.24. What is the ratio of the Aid flow (current US$) of Guinea-Bissau in 1996 to that in 2000?
Keep it short and to the point. 4.94. What is the ratio of the Aid flow (current US$) in Guyana in 1996 to that in 2000?
Offer a very short reply. 0.05. What is the ratio of the Aid flow (current US$) in Rwanda in 1996 to that in 2000?
Ensure brevity in your answer.  0.35. What is the ratio of the Aid flow (current US$) in Guinea-Bissau in 1996 to that in 2002?
Provide a succinct answer. 4.64. What is the ratio of the Aid flow (current US$) in Guyana in 1996 to that in 2002?
Make the answer very short. 0.02. What is the ratio of the Aid flow (current US$) in Rwanda in 1996 to that in 2002?
Offer a very short reply. 0.86. What is the ratio of the Aid flow (current US$) of Guinea-Bissau in 1997 to that in 2000?
Your answer should be compact. 3.65. What is the ratio of the Aid flow (current US$) in Guyana in 1997 to that in 2000?
Provide a short and direct response. 7.68. What is the ratio of the Aid flow (current US$) of Rwanda in 1997 to that in 2000?
Offer a very short reply. 1.46. What is the ratio of the Aid flow (current US$) of Guinea-Bissau in 1997 to that in 2002?
Provide a short and direct response. 3.42. What is the ratio of the Aid flow (current US$) in Guyana in 1997 to that in 2002?
Give a very brief answer. 2.56. What is the ratio of the Aid flow (current US$) of Rwanda in 1997 to that in 2002?
Your answer should be compact. 3.57. What is the ratio of the Aid flow (current US$) of Guinea-Bissau in 2000 to that in 2002?
Your answer should be very brief. 0.94. What is the ratio of the Aid flow (current US$) in Guyana in 2000 to that in 2002?
Give a very brief answer. 0.33. What is the ratio of the Aid flow (current US$) in Rwanda in 2000 to that in 2002?
Give a very brief answer. 2.45. What is the difference between the highest and the second highest Aid flow (current US$) in Guinea-Bissau?
Keep it short and to the point. 1.50e+05. What is the difference between the highest and the second highest Aid flow (current US$) of Guyana?
Keep it short and to the point. 1.78e+06. What is the difference between the highest and the second highest Aid flow (current US$) in Rwanda?
Offer a terse response. 5.50e+05. What is the difference between the highest and the lowest Aid flow (current US$) of Guinea-Bissau?
Make the answer very short. 1.51e+06. What is the difference between the highest and the lowest Aid flow (current US$) of Guyana?
Provide a succinct answer. 2.91e+06. What is the difference between the highest and the lowest Aid flow (current US$) of Pakistan?
Keep it short and to the point. 3.31e+06. What is the difference between the highest and the lowest Aid flow (current US$) of Rwanda?
Your answer should be compact. 1.71e+06. 